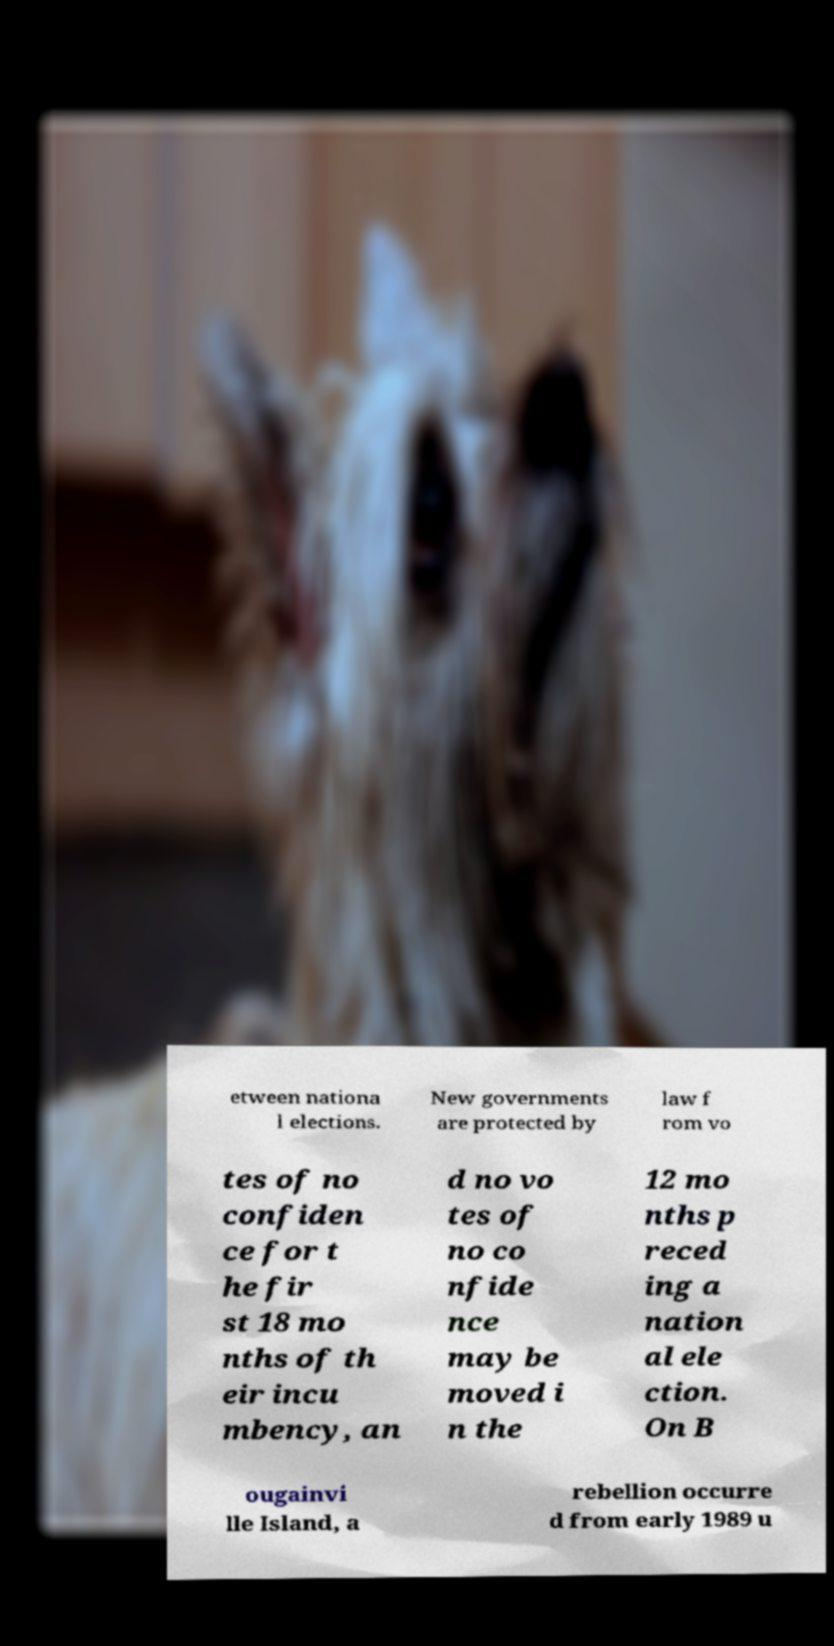Please read and relay the text visible in this image. What does it say? etween nationa l elections. New governments are protected by law f rom vo tes of no confiden ce for t he fir st 18 mo nths of th eir incu mbency, an d no vo tes of no co nfide nce may be moved i n the 12 mo nths p reced ing a nation al ele ction. On B ougainvi lle Island, a rebellion occurre d from early 1989 u 